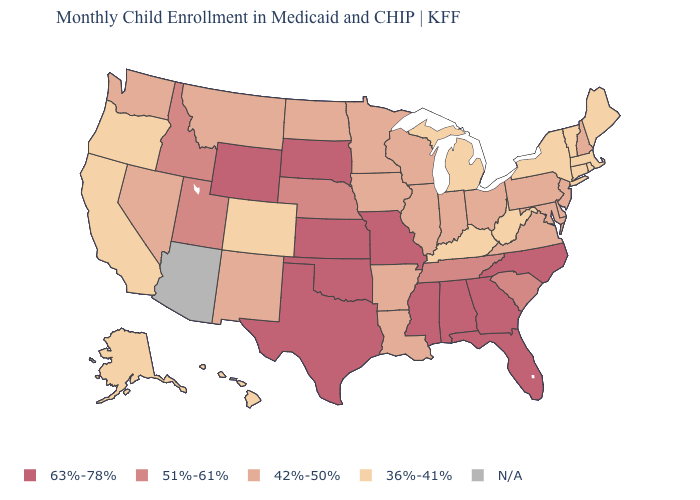Does the map have missing data?
Keep it brief. Yes. Which states have the highest value in the USA?
Short answer required. Alabama, Florida, Georgia, Kansas, Mississippi, Missouri, North Carolina, Oklahoma, South Dakota, Texas, Wyoming. Among the states that border Montana , which have the lowest value?
Give a very brief answer. North Dakota. What is the value of Utah?
Keep it brief. 51%-61%. Name the states that have a value in the range 36%-41%?
Short answer required. Alaska, California, Colorado, Connecticut, Hawaii, Kentucky, Maine, Massachusetts, Michigan, New York, Oregon, Rhode Island, Vermont, West Virginia. Does the first symbol in the legend represent the smallest category?
Quick response, please. No. What is the lowest value in the West?
Be succinct. 36%-41%. Among the states that border Ohio , which have the lowest value?
Answer briefly. Kentucky, Michigan, West Virginia. Does Massachusetts have the lowest value in the USA?
Be succinct. Yes. Among the states that border North Dakota , which have the highest value?
Write a very short answer. South Dakota. What is the value of New Hampshire?
Answer briefly. 42%-50%. Which states have the lowest value in the USA?
Be succinct. Alaska, California, Colorado, Connecticut, Hawaii, Kentucky, Maine, Massachusetts, Michigan, New York, Oregon, Rhode Island, Vermont, West Virginia. Does Georgia have the highest value in the USA?
Answer briefly. Yes. Name the states that have a value in the range 36%-41%?
Be succinct. Alaska, California, Colorado, Connecticut, Hawaii, Kentucky, Maine, Massachusetts, Michigan, New York, Oregon, Rhode Island, Vermont, West Virginia. Name the states that have a value in the range 63%-78%?
Write a very short answer. Alabama, Florida, Georgia, Kansas, Mississippi, Missouri, North Carolina, Oklahoma, South Dakota, Texas, Wyoming. 